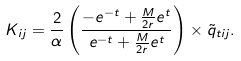<formula> <loc_0><loc_0><loc_500><loc_500>K _ { i j } = \frac { 2 } { \alpha } \left ( \frac { - e ^ { - t } + \frac { M } { 2 r } e ^ { t } } { e ^ { - t } + \frac { M } { 2 r } e ^ { t } } \right ) \times \tilde { q } _ { t i j } .</formula> 